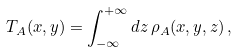<formula> <loc_0><loc_0><loc_500><loc_500>T _ { A } ( x , y ) = \int _ { - \infty } ^ { + \infty } d z \, \rho _ { A } ( x , y , z ) \, ,</formula> 